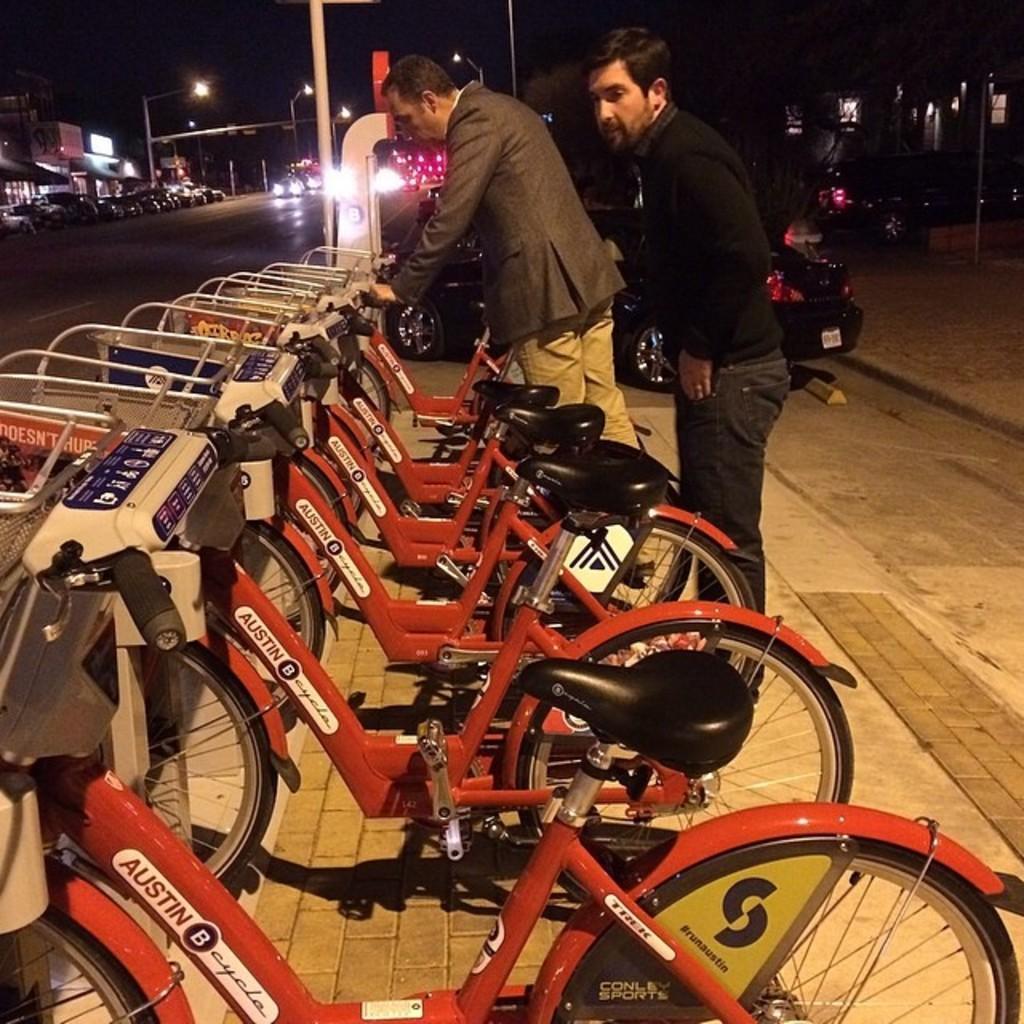How would you summarize this image in a sentence or two? In the middle of the image we can see some bicycles. Behind the bicycles two persons are standing. Beside them we can see some vehicles on the road. At the top of the image we can see some poles and buildings. 